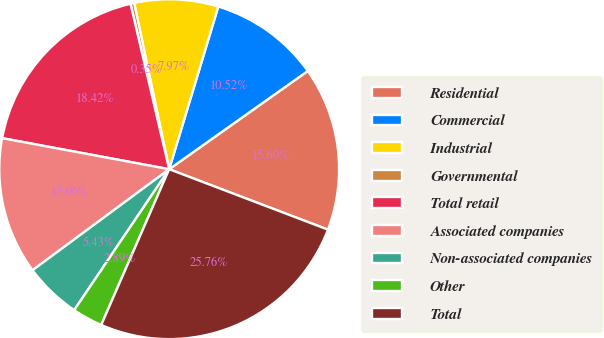<chart> <loc_0><loc_0><loc_500><loc_500><pie_chart><fcel>Residential<fcel>Commercial<fcel>Industrial<fcel>Governmental<fcel>Total retail<fcel>Associated companies<fcel>Non-associated companies<fcel>Other<fcel>Total<nl><fcel>15.6%<fcel>10.52%<fcel>7.97%<fcel>0.35%<fcel>18.42%<fcel>13.06%<fcel>5.43%<fcel>2.89%<fcel>25.76%<nl></chart> 